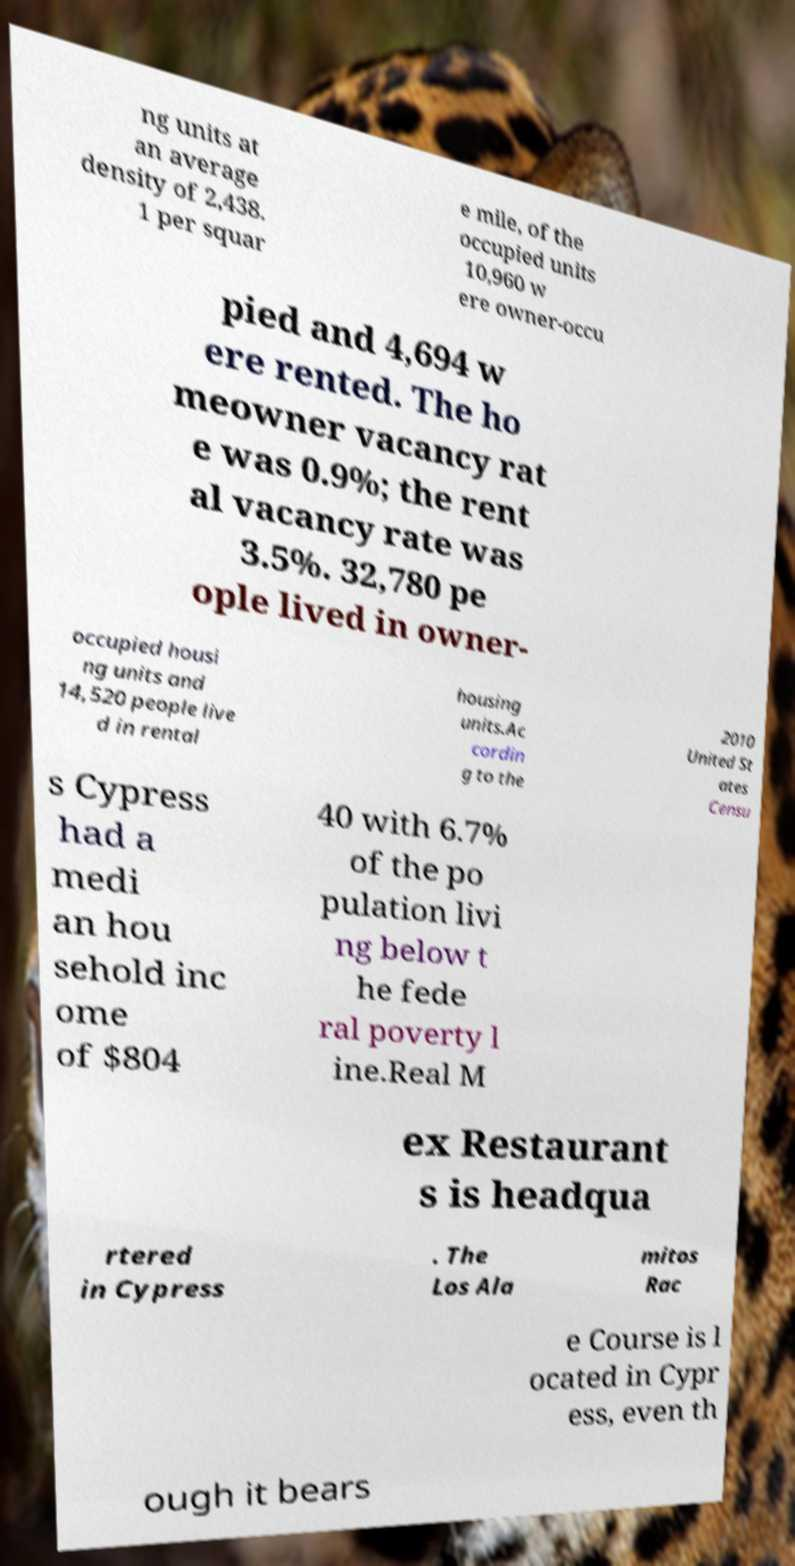Please read and relay the text visible in this image. What does it say? ng units at an average density of 2,438. 1 per squar e mile, of the occupied units 10,960 w ere owner-occu pied and 4,694 w ere rented. The ho meowner vacancy rat e was 0.9%; the rent al vacancy rate was 3.5%. 32,780 pe ople lived in owner- occupied housi ng units and 14,520 people live d in rental housing units.Ac cordin g to the 2010 United St ates Censu s Cypress had a medi an hou sehold inc ome of $804 40 with 6.7% of the po pulation livi ng below t he fede ral poverty l ine.Real M ex Restaurant s is headqua rtered in Cypress . The Los Ala mitos Rac e Course is l ocated in Cypr ess, even th ough it bears 